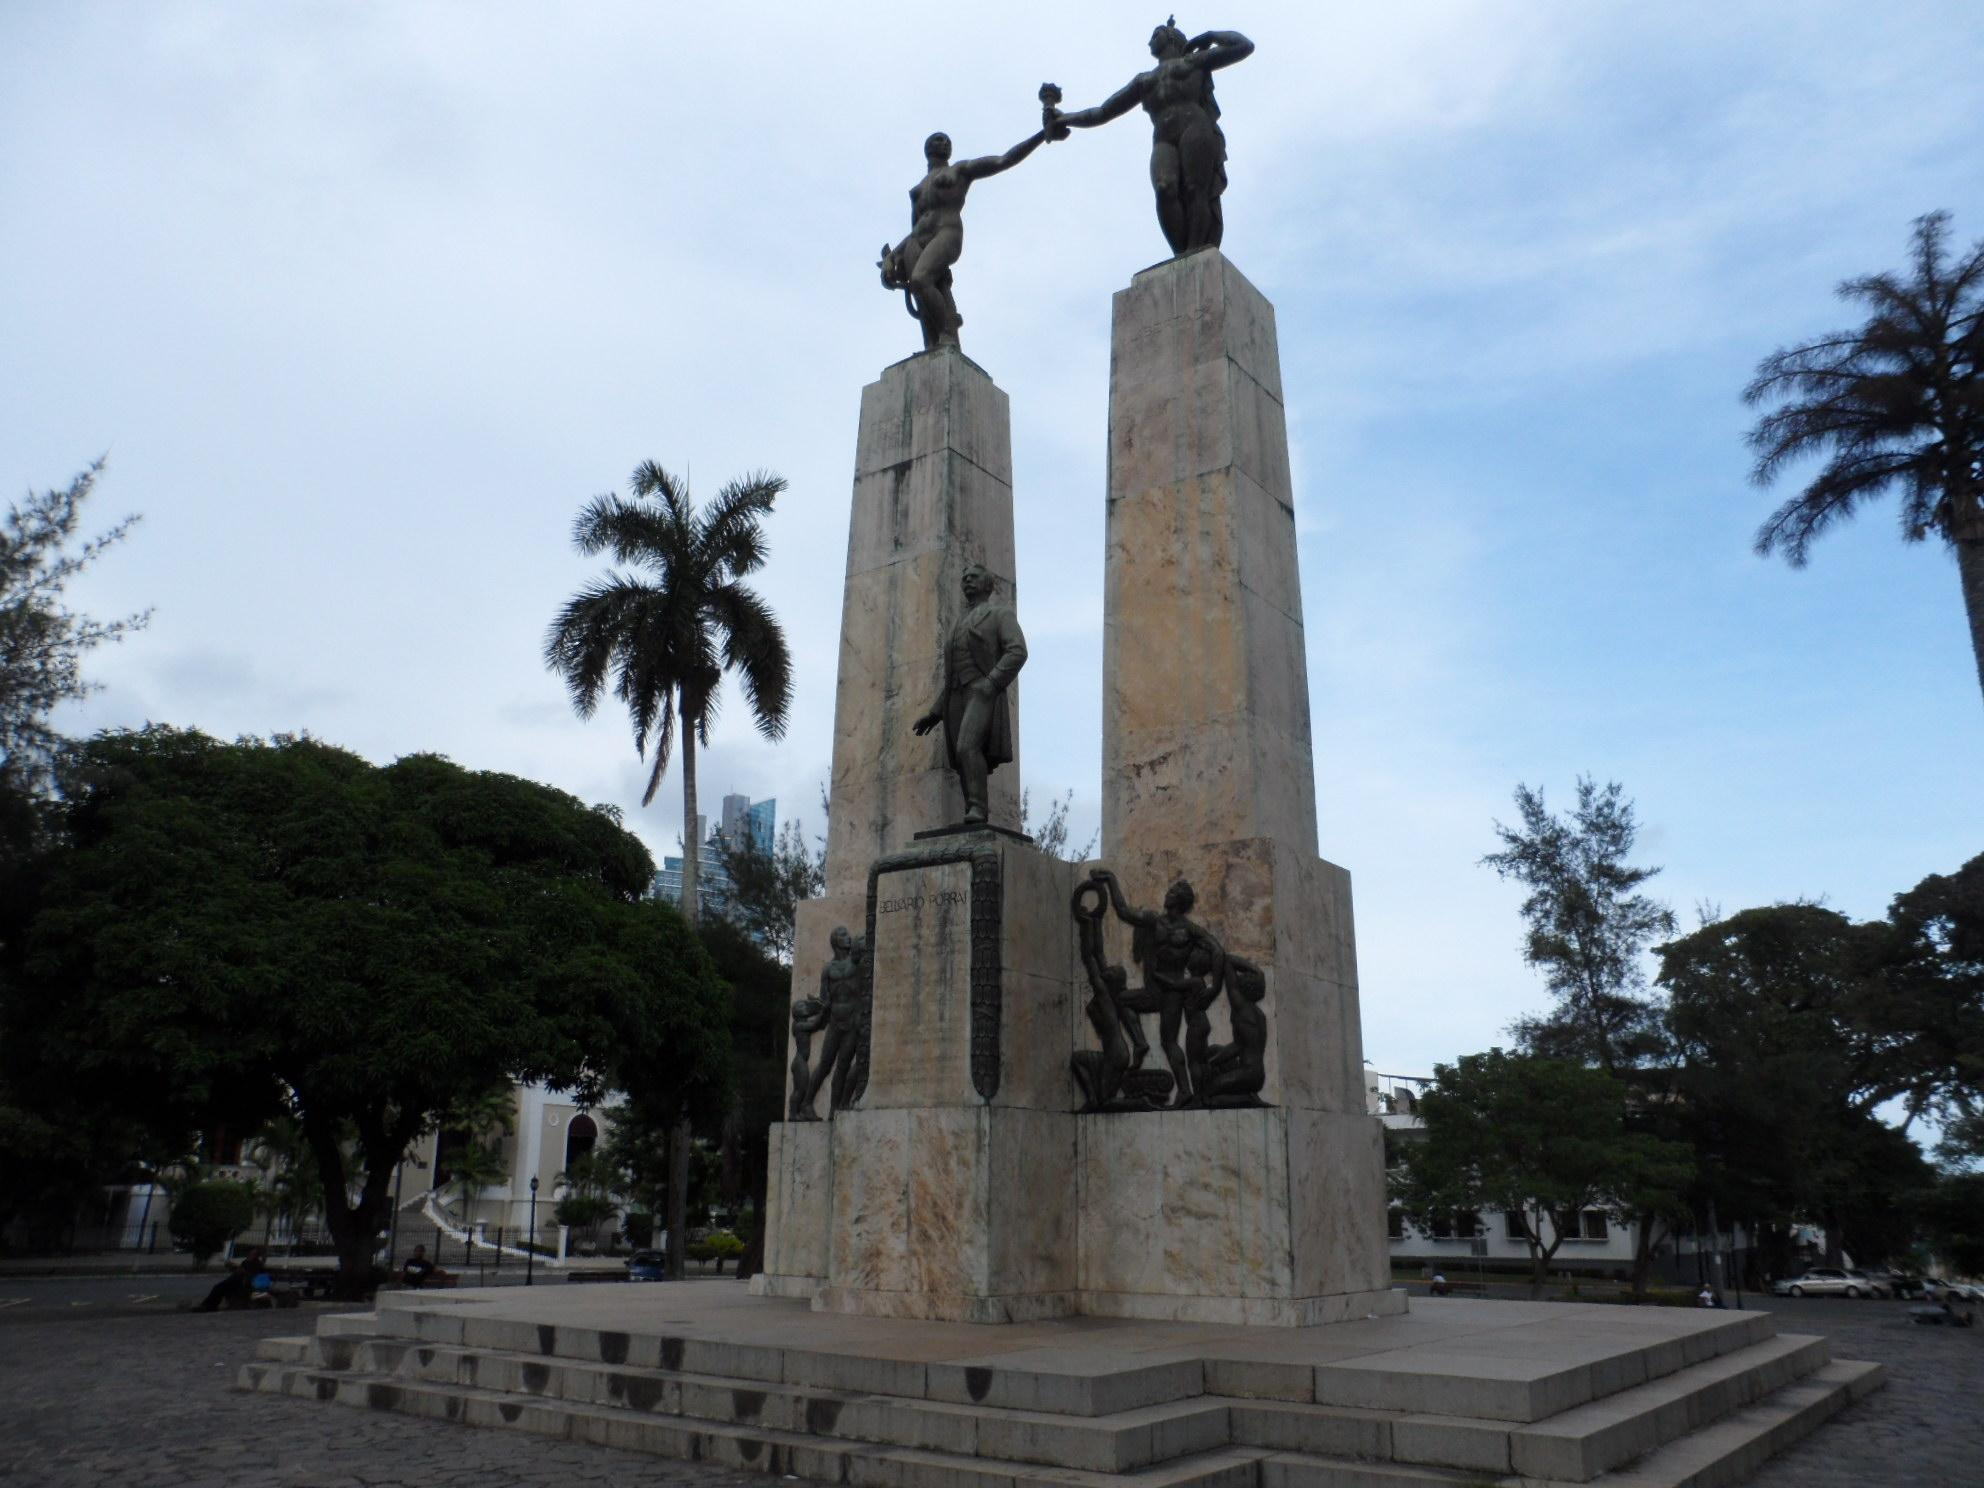What type of objects can be seen in the image? There are statues in the image. What can be seen in the background of the image? There are trees, buildings, and the sky visible in the background of the image. What type of sense can be seen in the image? There is no sense present in the image; it is a visual representation of statues, trees, buildings, and the sky. 